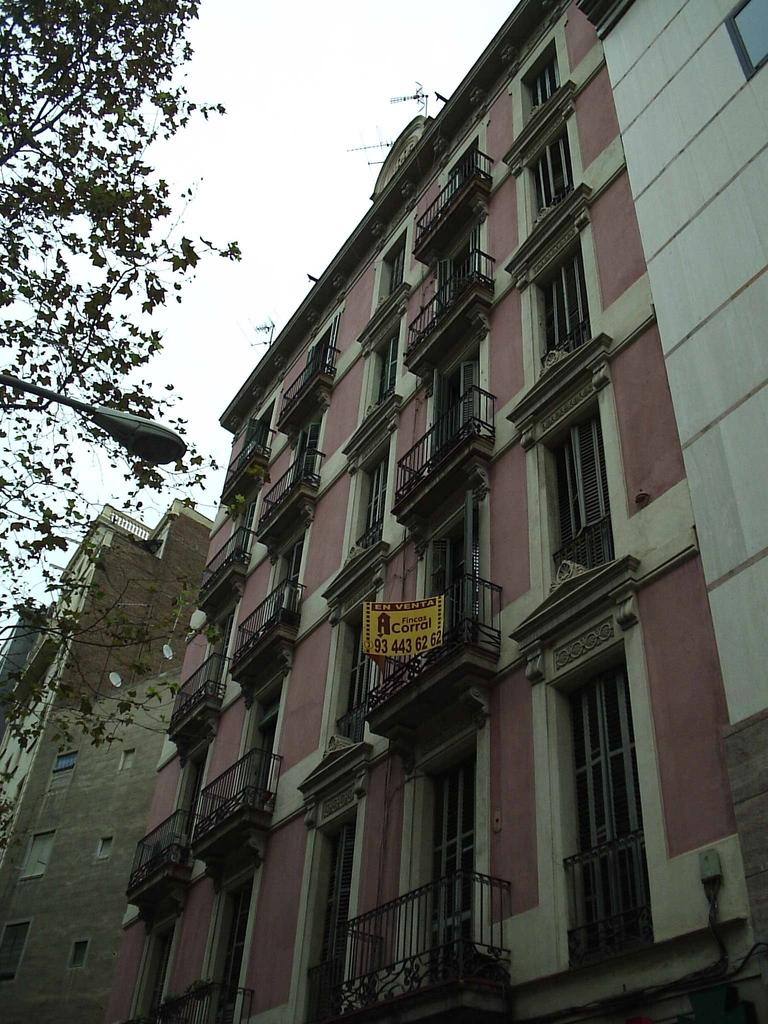What type of structures are present in the image? There are buildings in the image. What feature is common among these buildings? The buildings have many balcony windows. Are there any illumination sources on the buildings? Yes, the buildings have lights. What type of vegetation can be seen in the image? There are green leaves visible in the image. Can you describe the lighting conditions in the image? There is light in the image. What is the size of the territory occupied by the buildings in the image? The provided facts do not give information about the size of the territory occupied by the buildings, so it cannot be determined from the image. 